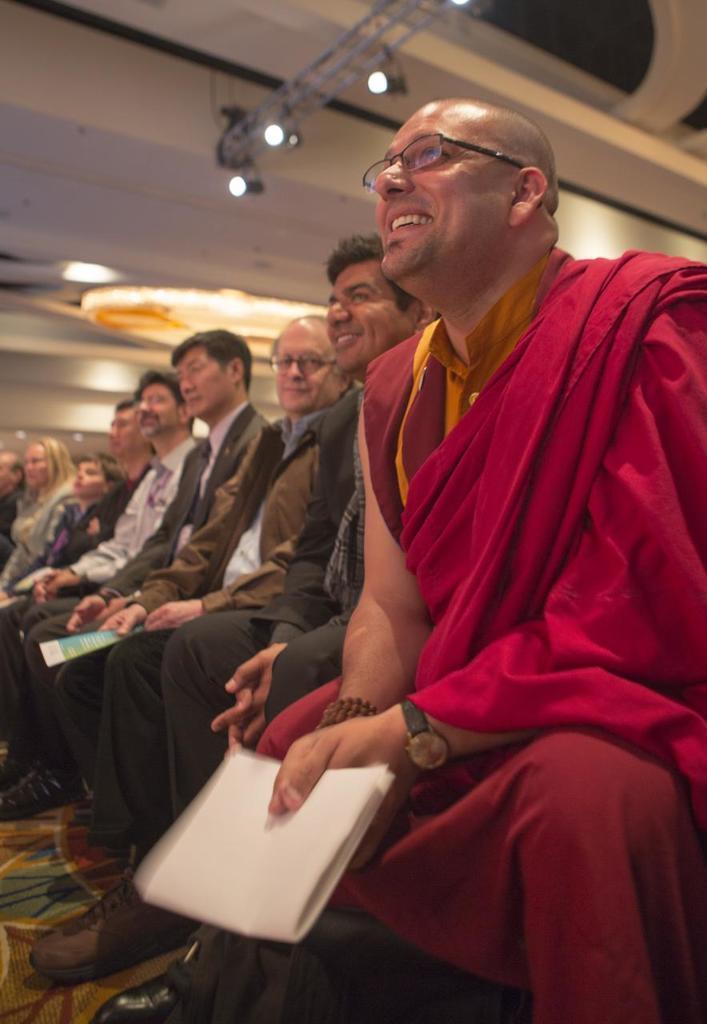In one or two sentences, can you explain what this image depicts? In this picture there are people sitting, among them there is a man smiling and holding papers and wore spectacle and we can see floor. At the top of the image we can see lights and rods. 